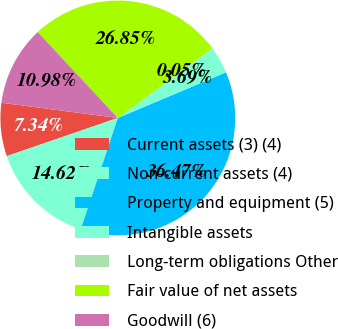<chart> <loc_0><loc_0><loc_500><loc_500><pie_chart><fcel>Current assets (3) (4)<fcel>Non-current assets (4)<fcel>Property and equipment (5)<fcel>Intangible assets<fcel>Long-term obligations Other<fcel>Fair value of net assets<fcel>Goodwill (6)<nl><fcel>7.34%<fcel>14.62%<fcel>36.47%<fcel>3.69%<fcel>0.05%<fcel>26.85%<fcel>10.98%<nl></chart> 